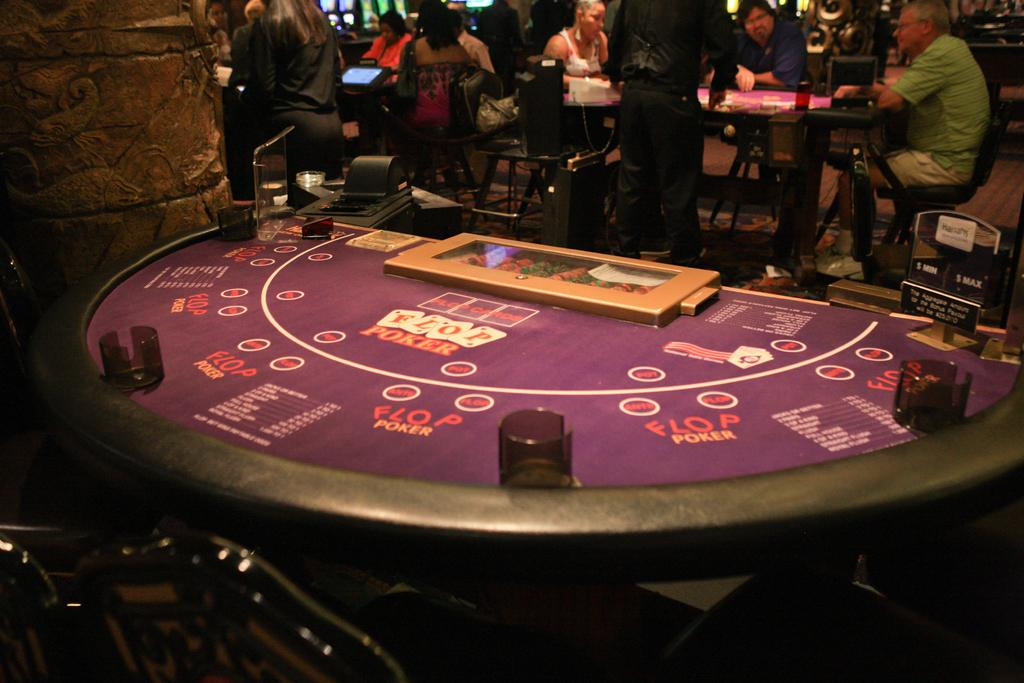What is the main piece of furniture in the image? There is a table in the image. What can be found on the table? There are objects on the table. Where are the people located in the image? In the top part of the image, there are people. What type of seating is present in the top part of the image? There are chairs in the top part of the image. Are there any other tables visible in the image? Yes, there are additional tables in the top part of the image. What kind of decorative elements can be seen in the top part of the image? Carvings are present in the top part of the image. What other objects can be found in the top part of the image? There are other objects in the top part of the image. How does the lumber contribute to the decoration of the image? There is no lumber present in the image; it is not a part of the decoration. 